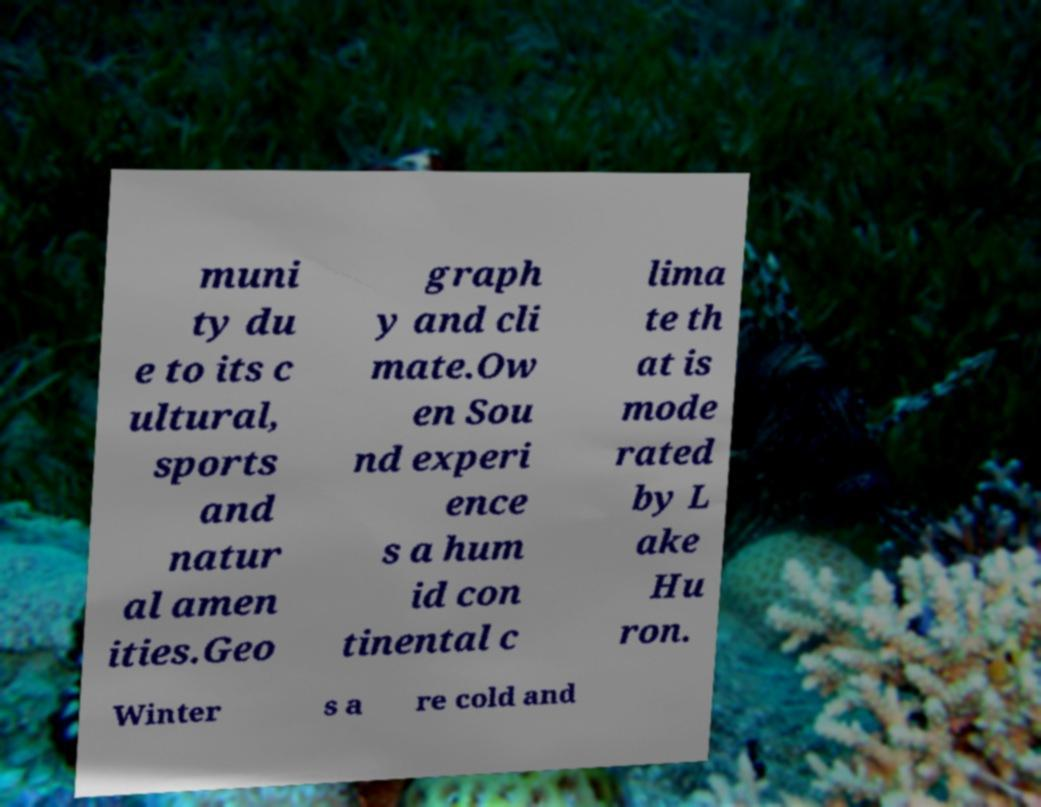What messages or text are displayed in this image? I need them in a readable, typed format. muni ty du e to its c ultural, sports and natur al amen ities.Geo graph y and cli mate.Ow en Sou nd experi ence s a hum id con tinental c lima te th at is mode rated by L ake Hu ron. Winter s a re cold and 